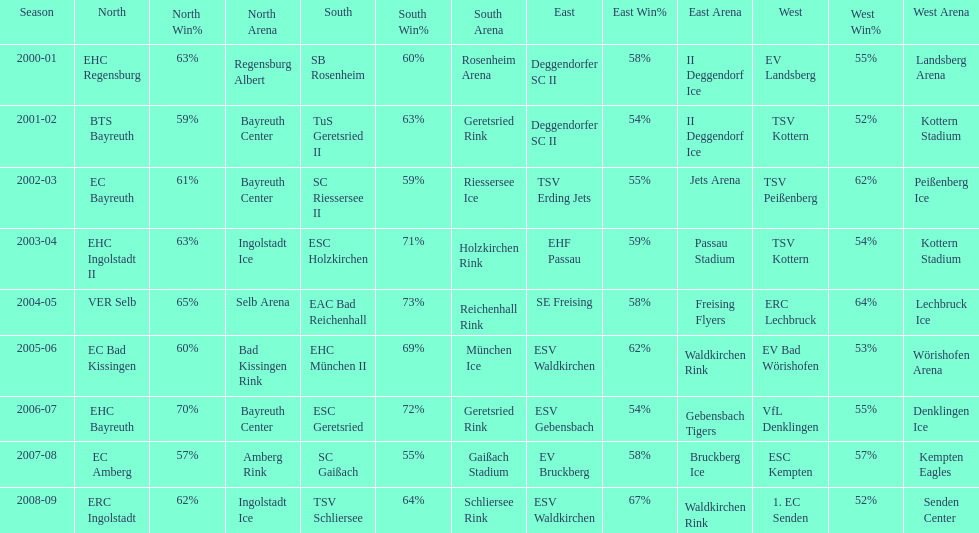The last team to win the west? 1. EC Senden. 